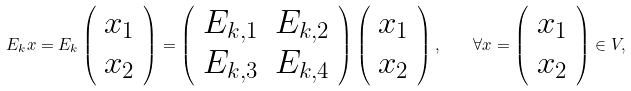<formula> <loc_0><loc_0><loc_500><loc_500>E _ { k } x = E _ { k } \left ( \begin{array} { c } x _ { 1 } \\ x _ { 2 } \end{array} \right ) = \left ( \begin{array} { c c } E _ { k , 1 } & E _ { k , 2 } \\ E _ { k , 3 } & E _ { k , 4 } \end{array} \right ) \left ( \begin{array} { c } x _ { 1 } \\ x _ { 2 } \end{array} \right ) , \quad \forall x = \left ( \begin{array} { c } x _ { 1 } \\ x _ { 2 } \end{array} \right ) \in V ,</formula> 